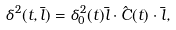Convert formula to latex. <formula><loc_0><loc_0><loc_500><loc_500>\delta ^ { 2 } ( t , \bar { l } ) = \delta _ { 0 } ^ { 2 } ( t ) \bar { l } \cdot \hat { C } ( t ) \cdot \bar { l } ,</formula> 